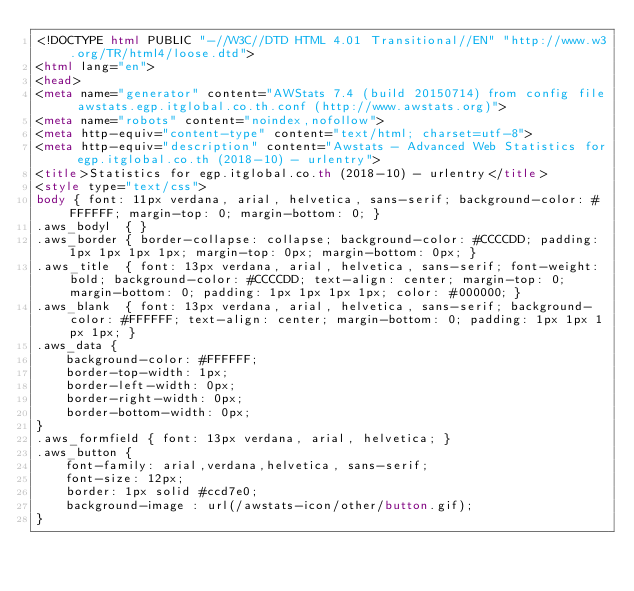Convert code to text. <code><loc_0><loc_0><loc_500><loc_500><_HTML_><!DOCTYPE html PUBLIC "-//W3C//DTD HTML 4.01 Transitional//EN" "http://www.w3.org/TR/html4/loose.dtd">
<html lang="en">
<head>
<meta name="generator" content="AWStats 7.4 (build 20150714) from config file awstats.egp.itglobal.co.th.conf (http://www.awstats.org)">
<meta name="robots" content="noindex,nofollow">
<meta http-equiv="content-type" content="text/html; charset=utf-8">
<meta http-equiv="description" content="Awstats - Advanced Web Statistics for egp.itglobal.co.th (2018-10) - urlentry">
<title>Statistics for egp.itglobal.co.th (2018-10) - urlentry</title>
<style type="text/css">
body { font: 11px verdana, arial, helvetica, sans-serif; background-color: #FFFFFF; margin-top: 0; margin-bottom: 0; }
.aws_bodyl  { }
.aws_border { border-collapse: collapse; background-color: #CCCCDD; padding: 1px 1px 1px 1px; margin-top: 0px; margin-bottom: 0px; }
.aws_title  { font: 13px verdana, arial, helvetica, sans-serif; font-weight: bold; background-color: #CCCCDD; text-align: center; margin-top: 0; margin-bottom: 0; padding: 1px 1px 1px 1px; color: #000000; }
.aws_blank  { font: 13px verdana, arial, helvetica, sans-serif; background-color: #FFFFFF; text-align: center; margin-bottom: 0; padding: 1px 1px 1px 1px; }
.aws_data {
	background-color: #FFFFFF;
	border-top-width: 1px;   
	border-left-width: 0px;  
	border-right-width: 0px; 
	border-bottom-width: 0px;
}
.aws_formfield { font: 13px verdana, arial, helvetica; }
.aws_button {
	font-family: arial,verdana,helvetica, sans-serif;
	font-size: 12px;
	border: 1px solid #ccd7e0;
	background-image : url(/awstats-icon/other/button.gif);
}</code> 